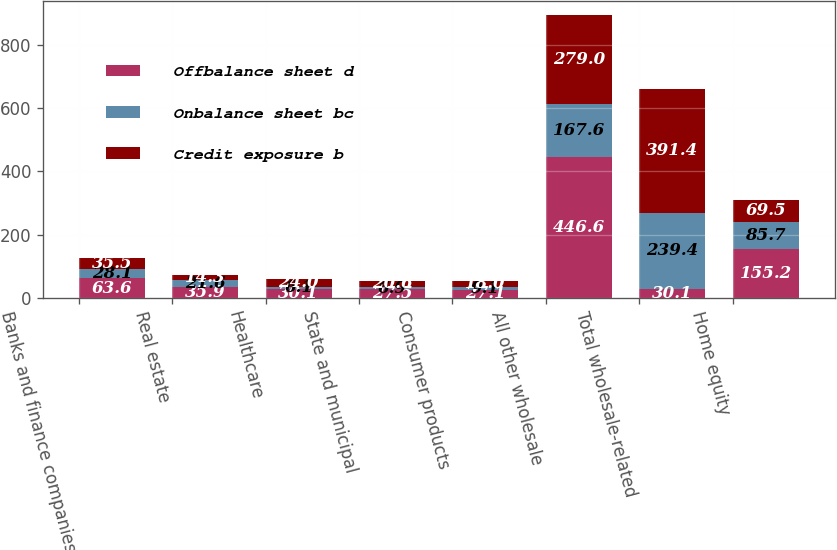<chart> <loc_0><loc_0><loc_500><loc_500><stacked_bar_chart><ecel><fcel>Banks and finance companies<fcel>Real estate<fcel>Healthcare<fcel>State and municipal<fcel>Consumer products<fcel>All other wholesale<fcel>Total wholesale-related<fcel>Home equity<nl><fcel>Offbalance sheet d<fcel>63.6<fcel>35.9<fcel>30.1<fcel>27.5<fcel>27.1<fcel>446.6<fcel>30.1<fcel>155.2<nl><fcel>Onbalance sheet bc<fcel>28.1<fcel>21.6<fcel>6.1<fcel>6.9<fcel>9.1<fcel>167.6<fcel>239.4<fcel>85.7<nl><fcel>Credit exposure b<fcel>35.5<fcel>14.3<fcel>24<fcel>20.6<fcel>18<fcel>279<fcel>391.4<fcel>69.5<nl></chart> 